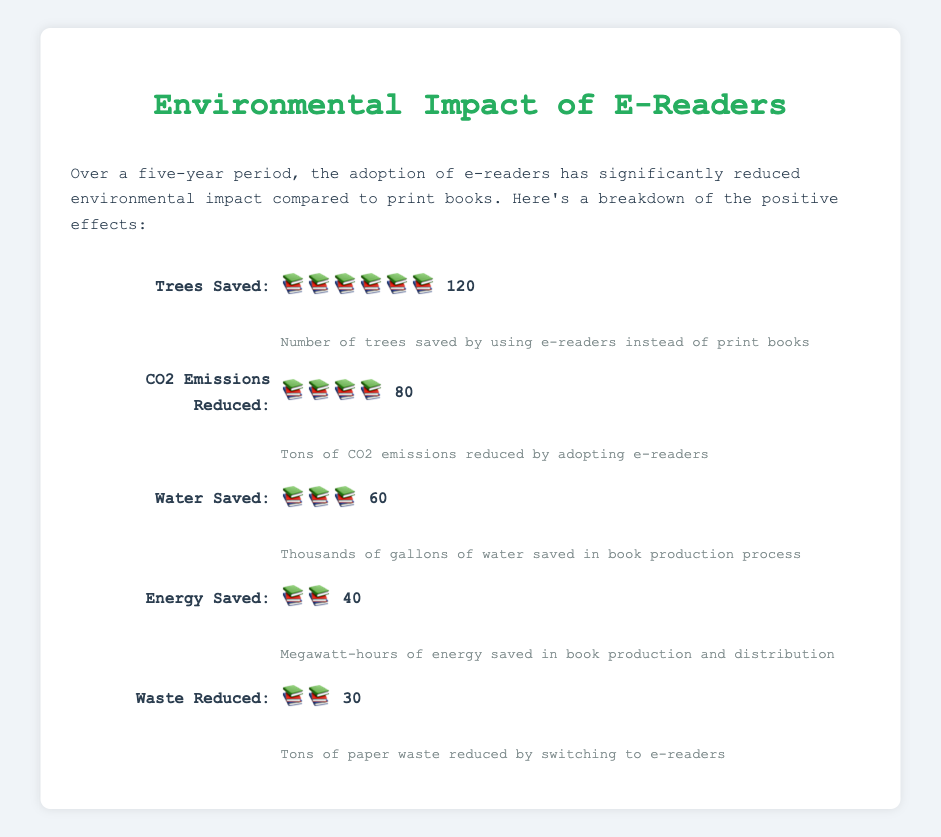What is the title of the figure? The title is usually placed at the top of the figure. The title for this figure is "Environmental Impact of E-Readers".
Answer: Environmental Impact of E-Readers How many trees are saved by using e-readers over five years? Look at the "Trees Saved" section of the figure. It mentions that 120 trees are saved.
Answer: 120 How many icons are used to represent CO2 Emissions Reduced? Each icon represents a certain quantity. For "CO2 Emissions Reduced", 4 icons are shown.
Answer: 4 Which category shows the greatest value? Compare all the values listed in each category. "Trees Saved" has the highest value at 120.
Answer: Trees Saved Compare the amount of water saved to the amount of energy saved. Which is higher? Comparing the values for "Water Saved" (60) and "Energy Saved" (40), "Water Saved" is higher.
Answer: Water Saved What is the total environmental impact reduction in terms of paper waste and energy saved? Add the values for "Waste Reduced" (30) and "Energy Saved" (40). The total is 30 + 40 = 70.
Answer: 70 How much more CO2 has been reduced compared to paper waste? Subtract the value of "Waste Reduced" (30) from "CO2 Emissions Reduced" (80). The difference is 80 - 30 = 50.
Answer: 50 Which environmental impact reduction category saves the least? Compare the values listed for each category. "Waste Reduced" has the lowest value at 30.
Answer: Waste Reduced What is the combined value of trees saved and water saved? Add the values of "Trees Saved" (120) and "Water Saved" (60). The total is 120 + 60 = 180.
Answer: 180 